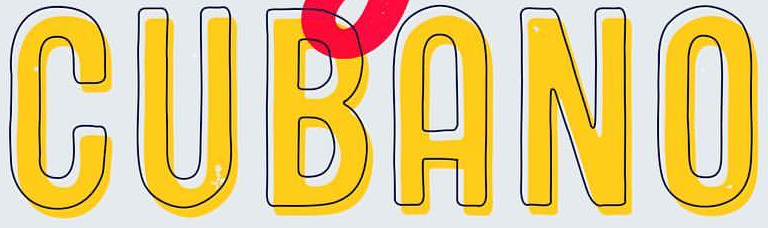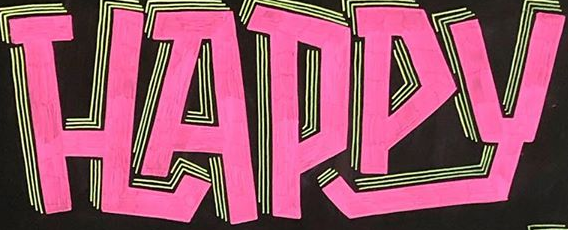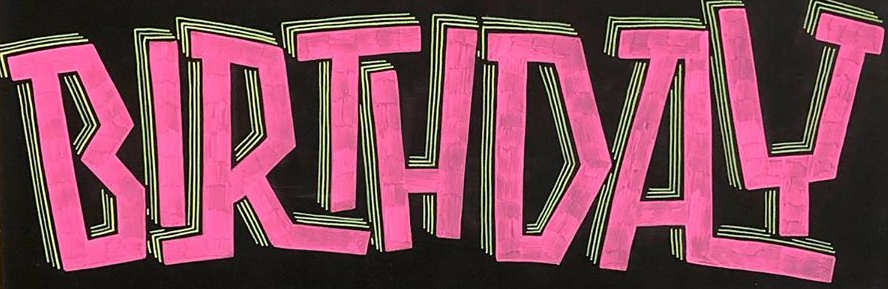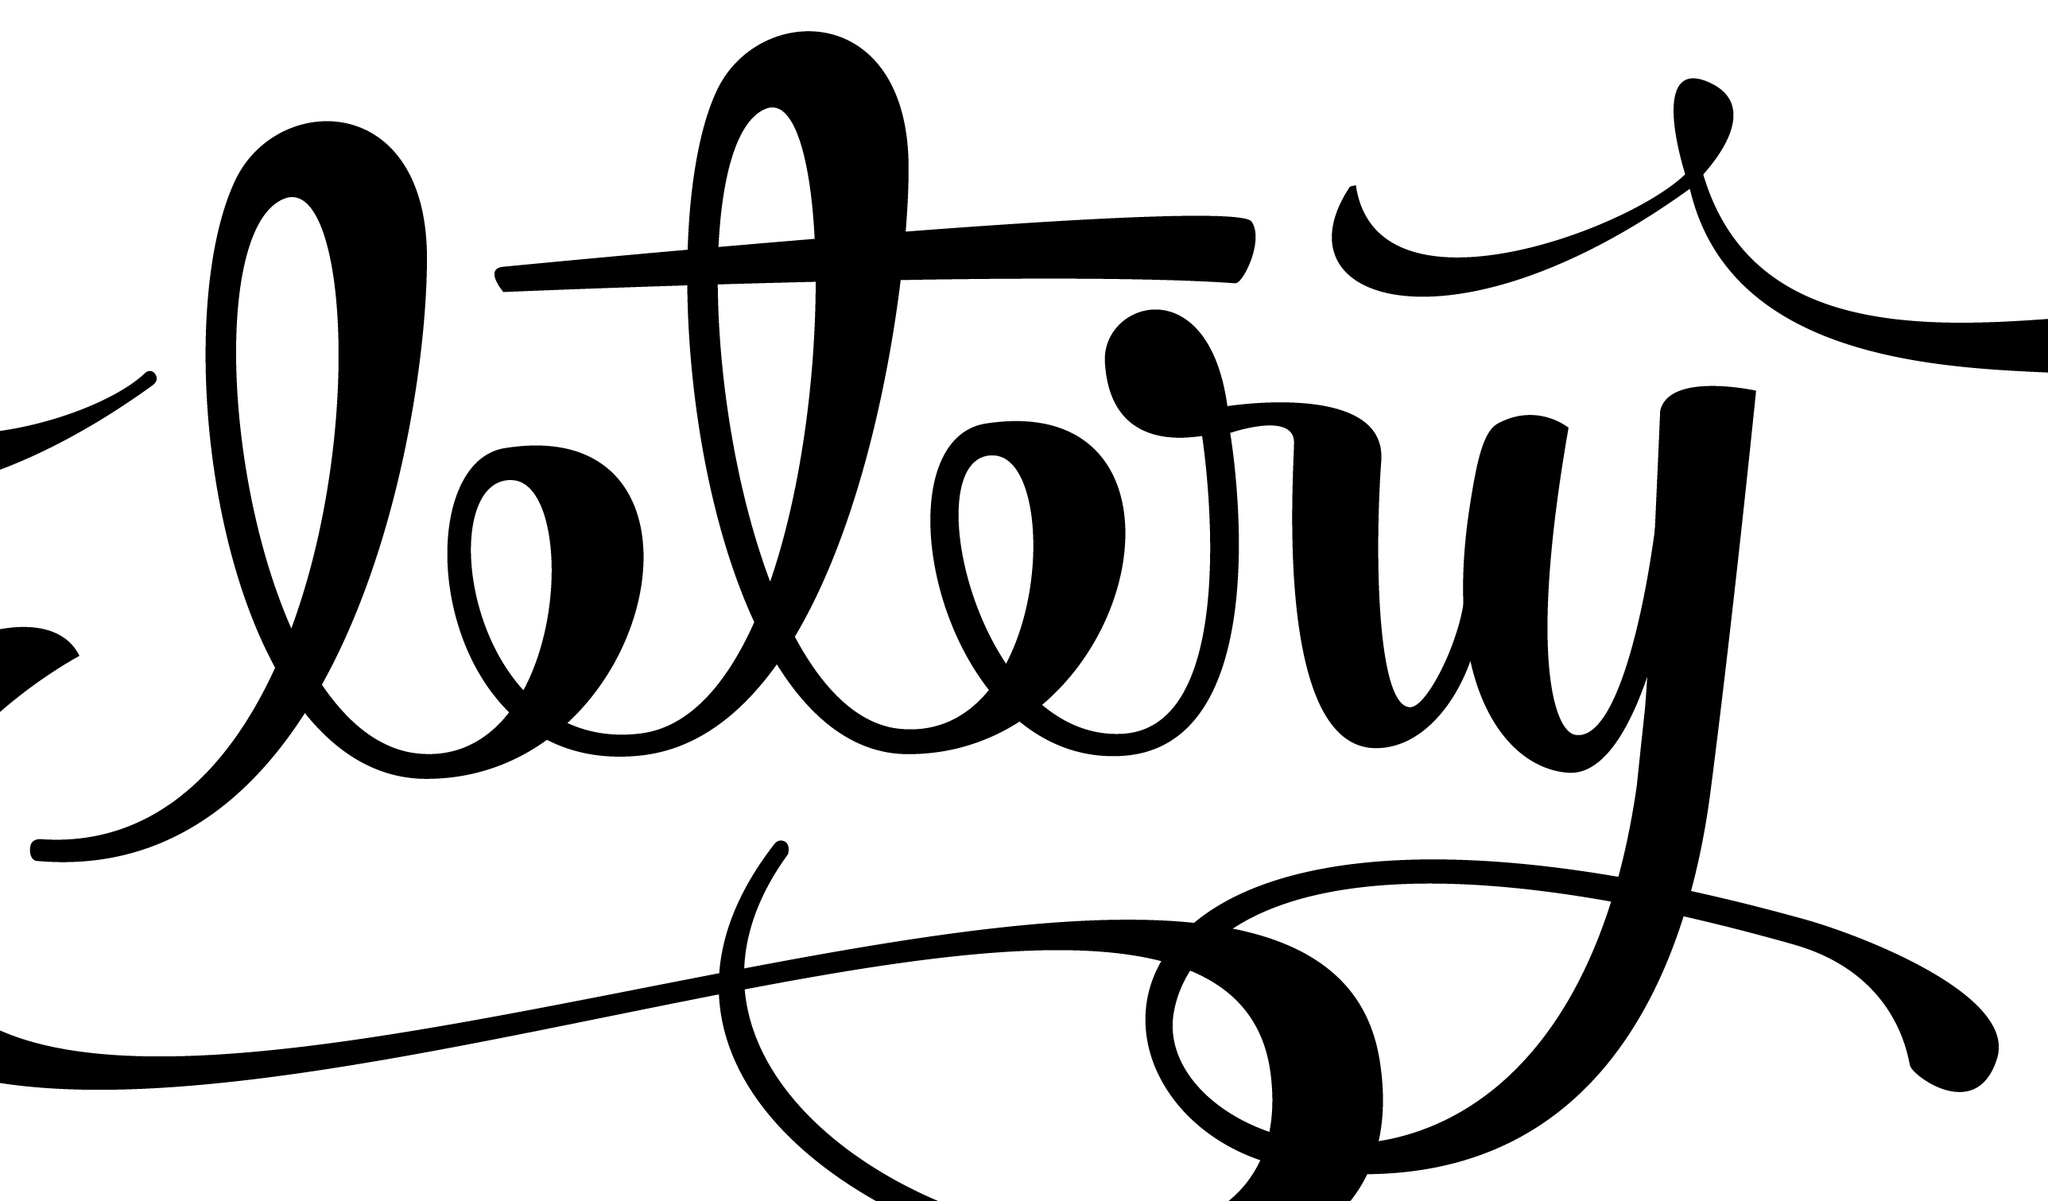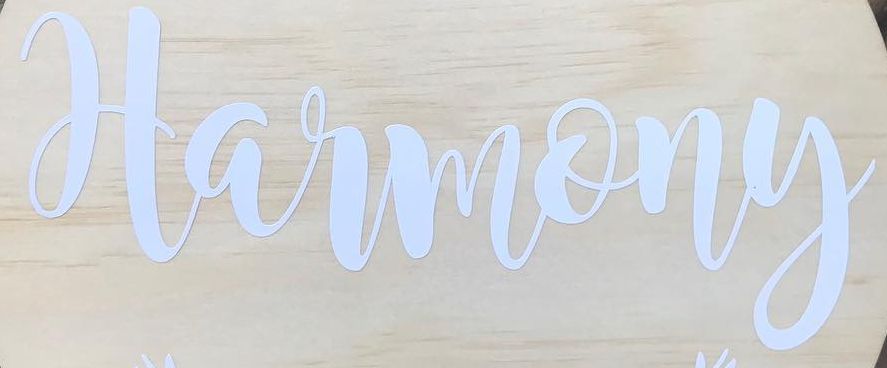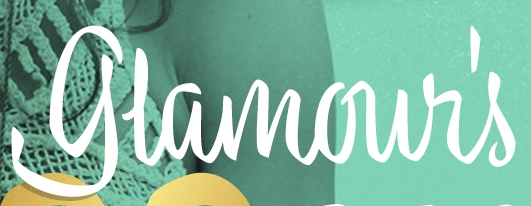What text appears in these images from left to right, separated by a semicolon? CUBANO; HAPPY; BIRTHDAY; ltry; Harmony; glamour's 